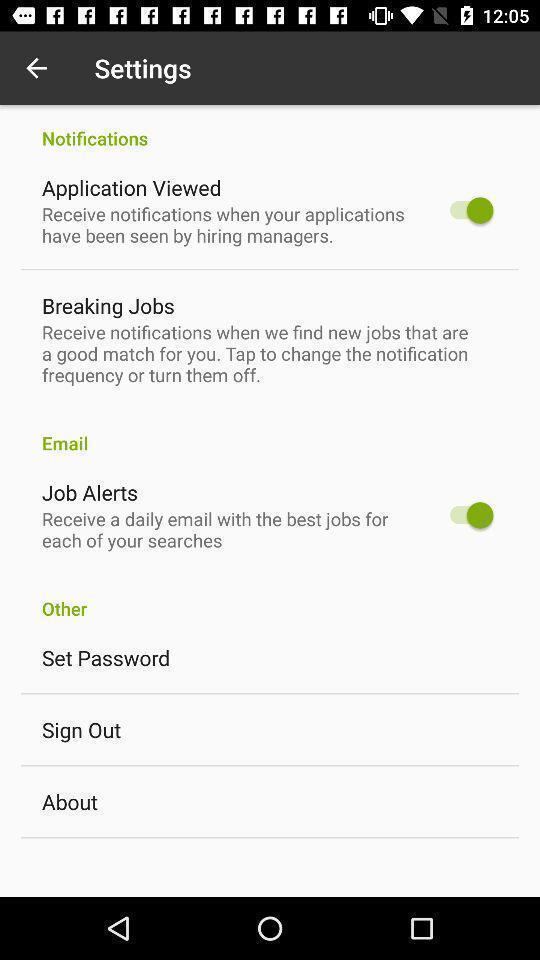Provide a description of this screenshot. Settings in job search app. 